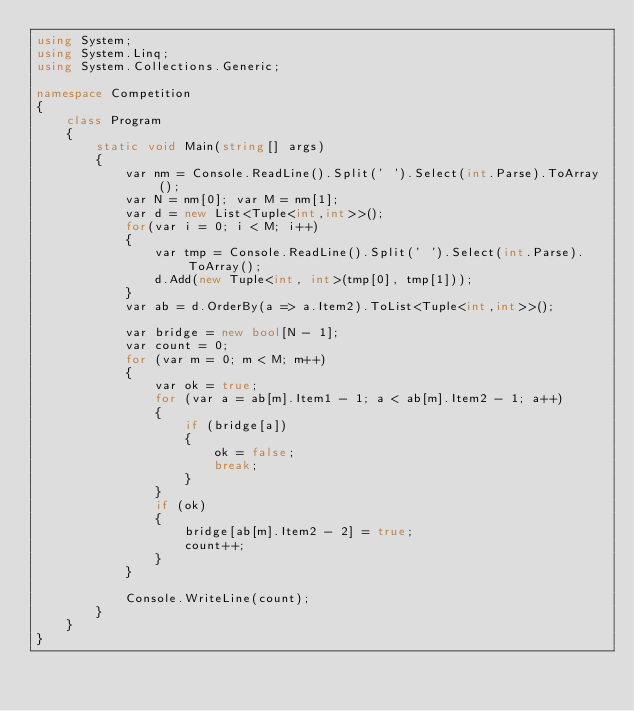Convert code to text. <code><loc_0><loc_0><loc_500><loc_500><_C#_>using System;
using System.Linq;
using System.Collections.Generic;

namespace Competition
{
    class Program
    {
        static void Main(string[] args)
        {
            var nm = Console.ReadLine().Split(' ').Select(int.Parse).ToArray();
            var N = nm[0]; var M = nm[1];
            var d = new List<Tuple<int,int>>();
            for(var i = 0; i < M; i++)
            {
                var tmp = Console.ReadLine().Split(' ').Select(int.Parse).ToArray();
                d.Add(new Tuple<int, int>(tmp[0], tmp[1]));
            }
            var ab = d.OrderBy(a => a.Item2).ToList<Tuple<int,int>>();

            var bridge = new bool[N - 1];
            var count = 0;
            for (var m = 0; m < M; m++)
            {
                var ok = true;
                for (var a = ab[m].Item1 - 1; a < ab[m].Item2 - 1; a++)
                {
                    if (bridge[a])
                    {
                        ok = false;
                        break;
                    }
                }
                if (ok)
                {
                    bridge[ab[m].Item2 - 2] = true;
                    count++;
                }
            }
                
            Console.WriteLine(count);
        }
    }
}
</code> 